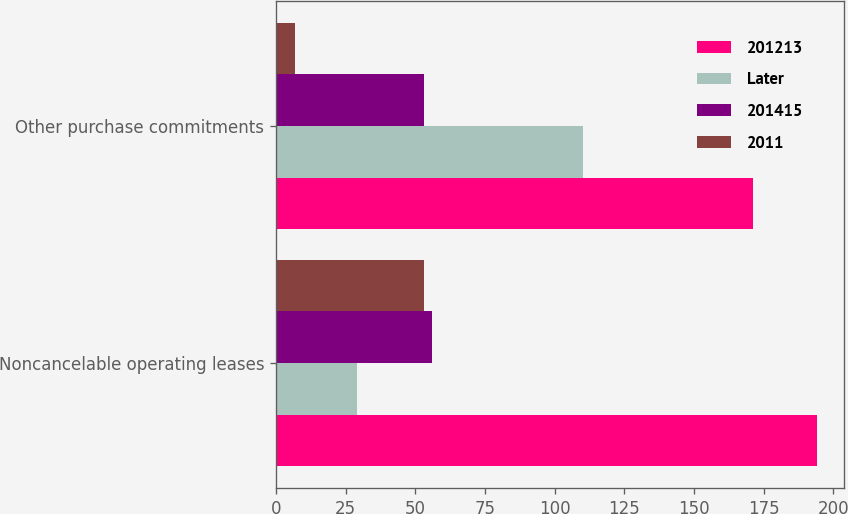<chart> <loc_0><loc_0><loc_500><loc_500><stacked_bar_chart><ecel><fcel>Noncancelable operating leases<fcel>Other purchase commitments<nl><fcel>201213<fcel>194<fcel>171<nl><fcel>Later<fcel>29<fcel>110<nl><fcel>201415<fcel>56<fcel>53<nl><fcel>2011<fcel>53<fcel>7<nl></chart> 